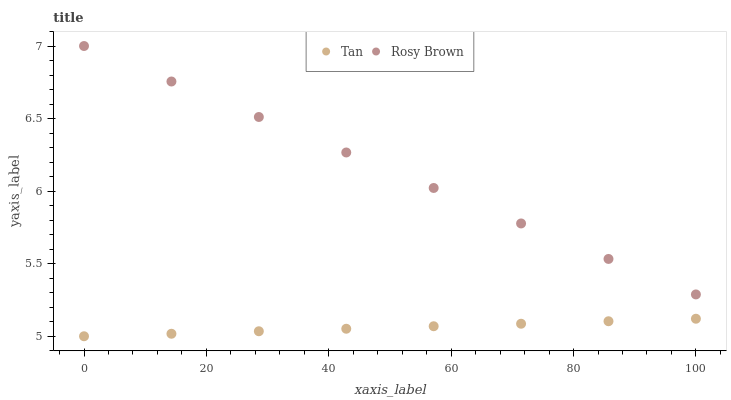Does Tan have the minimum area under the curve?
Answer yes or no. Yes. Does Rosy Brown have the maximum area under the curve?
Answer yes or no. Yes. Does Rosy Brown have the minimum area under the curve?
Answer yes or no. No. Is Rosy Brown the smoothest?
Answer yes or no. Yes. Is Tan the roughest?
Answer yes or no. Yes. Is Rosy Brown the roughest?
Answer yes or no. No. Does Tan have the lowest value?
Answer yes or no. Yes. Does Rosy Brown have the lowest value?
Answer yes or no. No. Does Rosy Brown have the highest value?
Answer yes or no. Yes. Is Tan less than Rosy Brown?
Answer yes or no. Yes. Is Rosy Brown greater than Tan?
Answer yes or no. Yes. Does Tan intersect Rosy Brown?
Answer yes or no. No. 